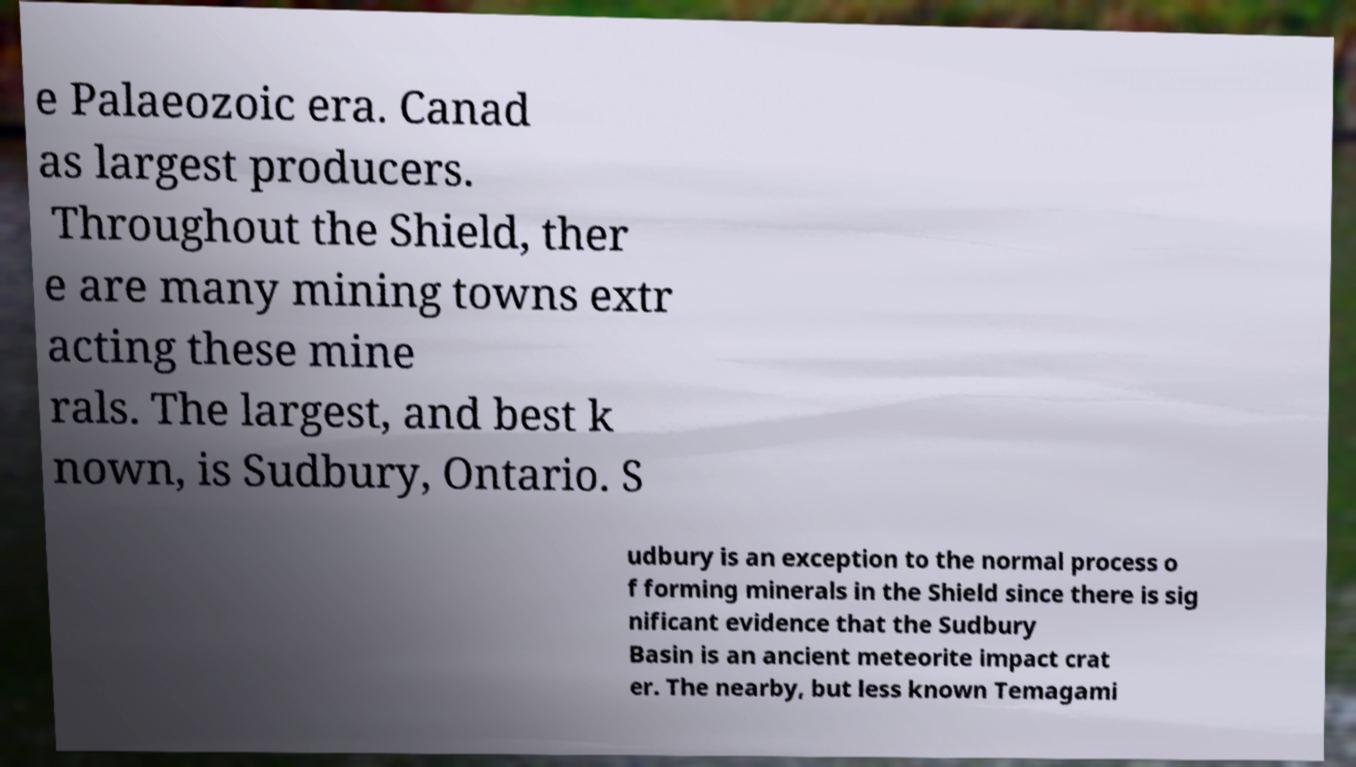Can you read and provide the text displayed in the image?This photo seems to have some interesting text. Can you extract and type it out for me? e Palaeozoic era. Canad as largest producers. Throughout the Shield, ther e are many mining towns extr acting these mine rals. The largest, and best k nown, is Sudbury, Ontario. S udbury is an exception to the normal process o f forming minerals in the Shield since there is sig nificant evidence that the Sudbury Basin is an ancient meteorite impact crat er. The nearby, but less known Temagami 